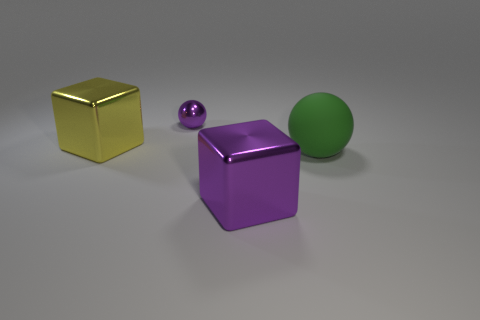Subtract 1 cubes. How many cubes are left? 1 Subtract all yellow cylinders. How many purple cubes are left? 1 Add 4 large things. How many large things are left? 7 Add 3 large cyan metallic things. How many large cyan metallic things exist? 3 Add 1 spheres. How many objects exist? 5 Subtract 0 cyan cylinders. How many objects are left? 4 Subtract all red blocks. Subtract all blue balls. How many blocks are left? 2 Subtract all tiny gray shiny things. Subtract all matte spheres. How many objects are left? 3 